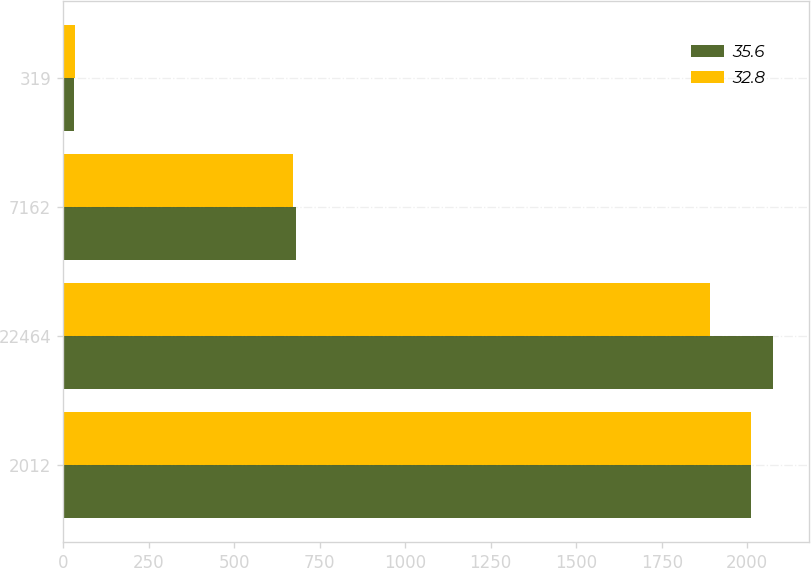Convert chart. <chart><loc_0><loc_0><loc_500><loc_500><stacked_bar_chart><ecel><fcel>2012<fcel>22464<fcel>7162<fcel>319<nl><fcel>35.6<fcel>2011<fcel>2076.8<fcel>680.3<fcel>32.8<nl><fcel>32.8<fcel>2010<fcel>1890.8<fcel>673.4<fcel>35.6<nl></chart> 